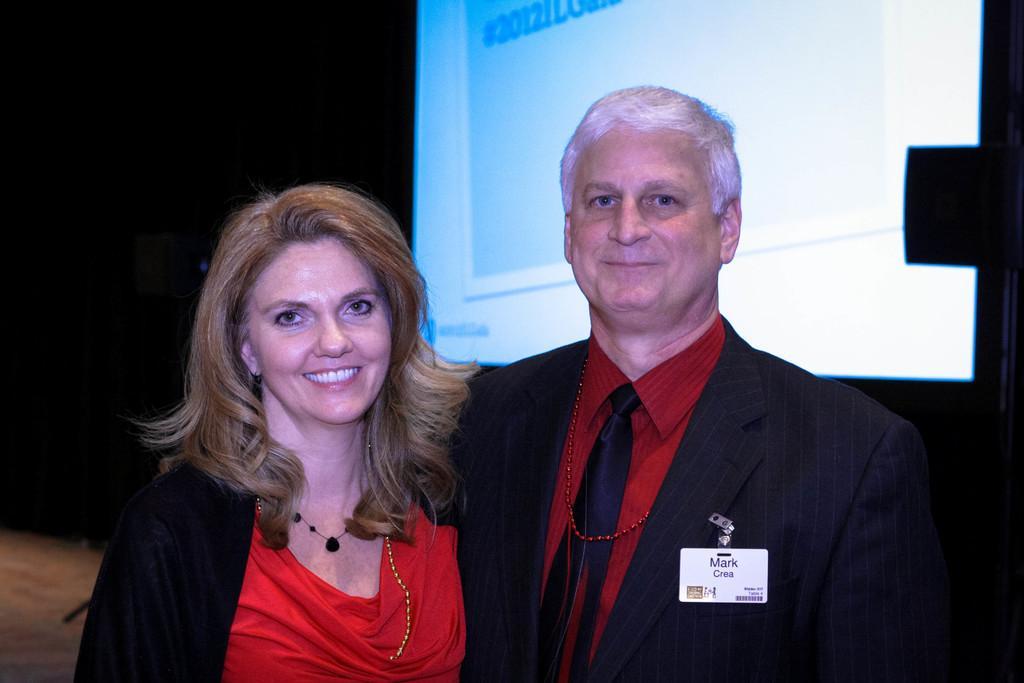How would you summarize this image in a sentence or two? In this image in the front there are persons standing and smiling. In the background there is a screen with some numbers displaying on it. 